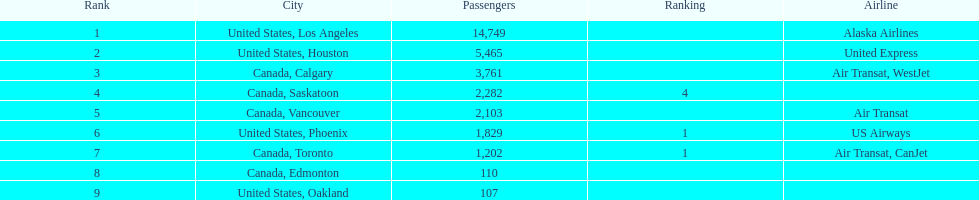Which airline carries the most passengers? Alaska Airlines. 